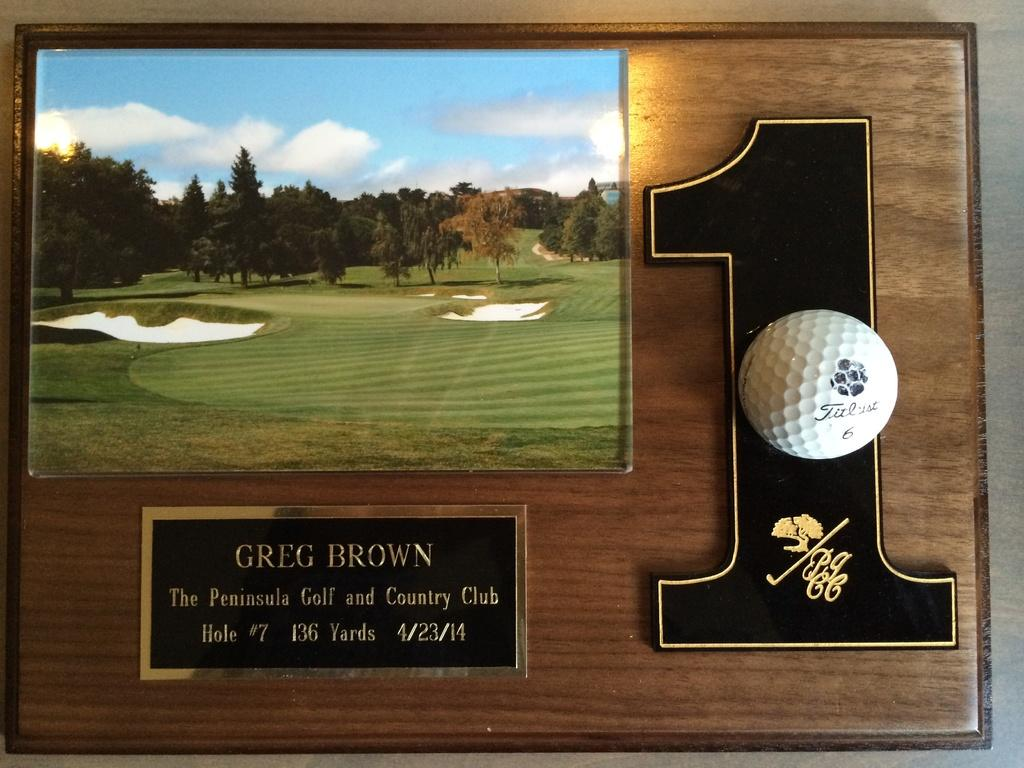<image>
Render a clear and concise summary of the photo. A plaque that shows a golf course and a number 1 with a title that says Greg Brown 